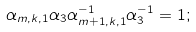<formula> <loc_0><loc_0><loc_500><loc_500>\alpha _ { m , k , 1 } \alpha _ { 3 } \alpha _ { m + 1 , k , 1 } ^ { - 1 } \alpha _ { 3 } ^ { - 1 } = 1 ;</formula> 